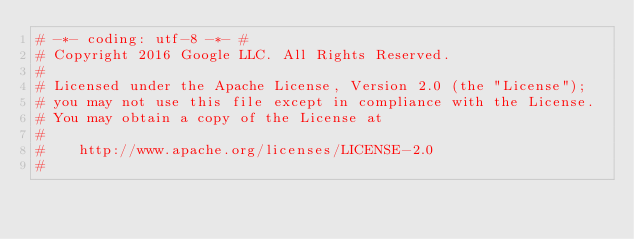Convert code to text. <code><loc_0><loc_0><loc_500><loc_500><_Python_># -*- coding: utf-8 -*- #
# Copyright 2016 Google LLC. All Rights Reserved.
#
# Licensed under the Apache License, Version 2.0 (the "License");
# you may not use this file except in compliance with the License.
# You may obtain a copy of the License at
#
#    http://www.apache.org/licenses/LICENSE-2.0
#</code> 